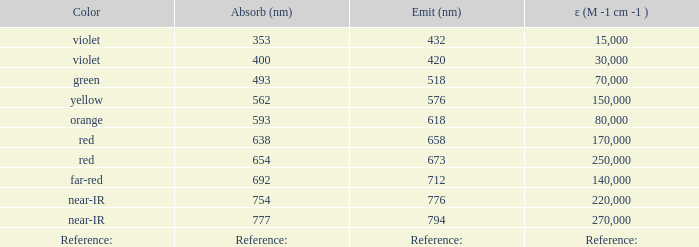What is the Absorbtion (in nanometers) of the color Orange? 593.0. 